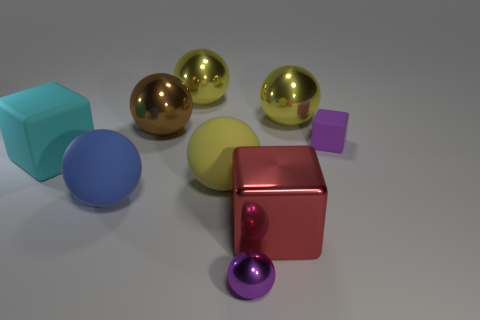Subtract all yellow balls. How many were subtracted if there are1yellow balls left? 2 Subtract all brown metal spheres. How many spheres are left? 5 Subtract all cyan balls. How many purple cubes are left? 1 Subtract all purple cubes. How many cubes are left? 2 Add 7 small purple cylinders. How many small purple cylinders exist? 7 Subtract 0 cyan cylinders. How many objects are left? 9 Subtract all spheres. How many objects are left? 3 Subtract all yellow spheres. Subtract all gray cylinders. How many spheres are left? 3 Subtract all yellow spheres. Subtract all blue matte balls. How many objects are left? 5 Add 8 large rubber spheres. How many large rubber spheres are left? 10 